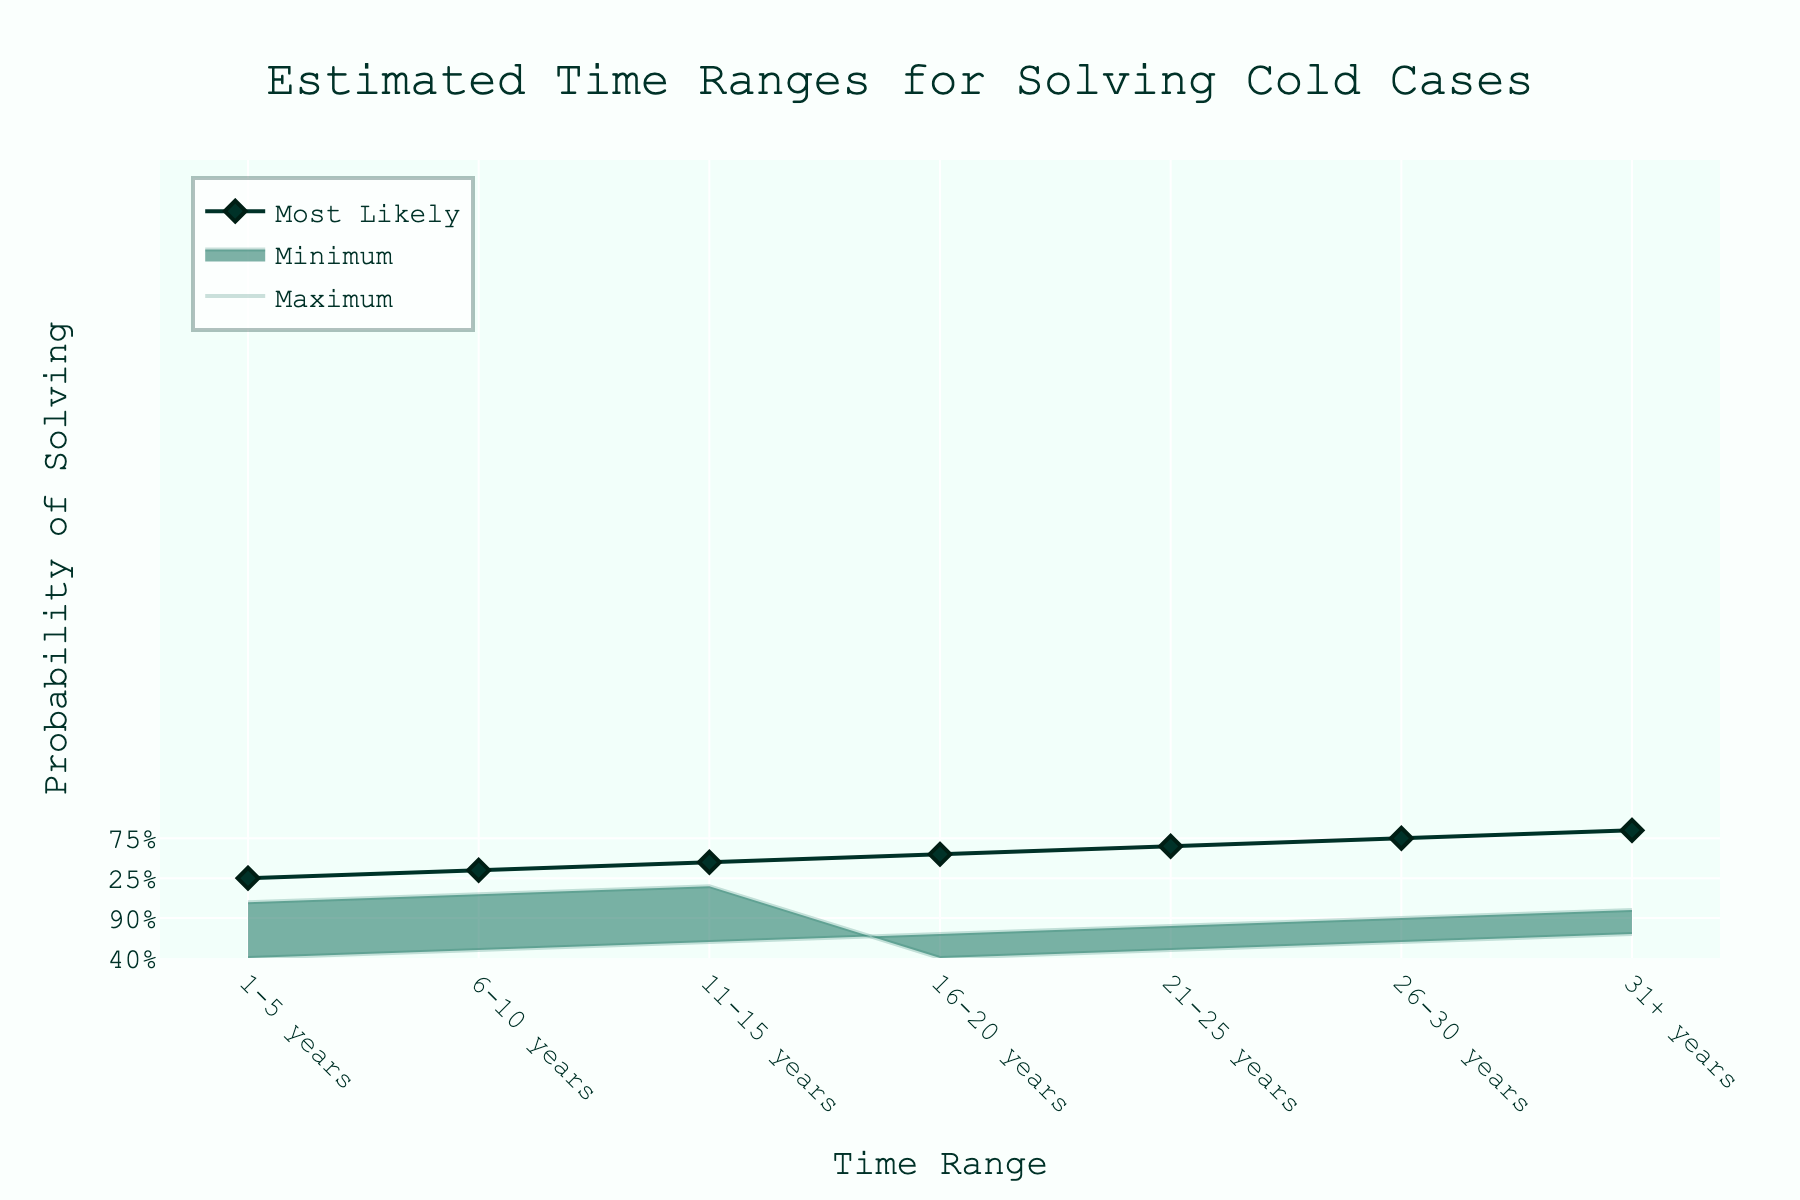what is the title of the figure? The title of the figure is found at the top and is centered. It is in a larger font than the rest of the text.
Answer: Estimated Time Ranges for Solving Cold Cases What time range has the highest minimum probability of solving cold cases? By looking at the data points with the label "Minimum" on the y-axis, the one with the highest value corresponds to the range "31+ years."
Answer: 31+ years How does the probability of solving cold cases likely change as time progresses? By observing the "Most Likely" line, it is clear that as time passes, the probability increases steadily from 1-5 years up to 31+ years.
Answer: Increases In the 16-20 years range, what is the difference between the maximum and minimum probabilities of solving cold cases? For the 16-20 years time range, the maximum probability is 70% and the minimum is 40%. The difference is calculated as 70% - 40%
Answer: 30% Is it more likely to solve a cold case in the first 1-5 years or the 21-25 years range? By comparing the "Most Likely" line for both ranges, 21-25 years has a higher value (65%) compared to 1-5 years (25%).
Answer: 21-25 years Which range sees the greatest increase in the 'Most Likely' probability of solving cold cases? By looking at the steepness of the "Most Likely" line, the largest gap occurs between the 1-5 years range and the 6-10 years range, rising from 25% to 35%.
Answer: 1-5 to 6-10 years What pattern do you notice in the 'Maximum' probabilities as time increases? Observing the trend in the 'Maximum' line, the probability consistently increases as the time ranges extend from 1-5 years to 31+ years.
Answer: Increases For the time range of 6-10 years, what is the average probability of solving cold cases considering all three estimates (minimum, most likely, maximum)? Add together the three probabilities for 6-10 years (20% + 35% + 50%) = 105%, then divide by 3 for the average, which is 105/3
Answer: 35% How does the 'Most Likely' probability in the 11-15 years range compare to that in the 26-30 years range? By comparing the probabilities on the 'Most Likely' line, the 11-15 years range shows 45%, and the 26-30 years range shows 75%. The comparison shows that 26-30 years has a higher probability.
Answer: 26-30 years is higher In which time range is the difference between the Most Likely and Minimum probabilities smallest? The smallest difference between the 'Most Likely' and 'Minimum' probabilities can be found by observing where the gap is least. In the data, this happens within the first 1-5 years range (25% - 10% = 15%).
Answer: 1-5 years 